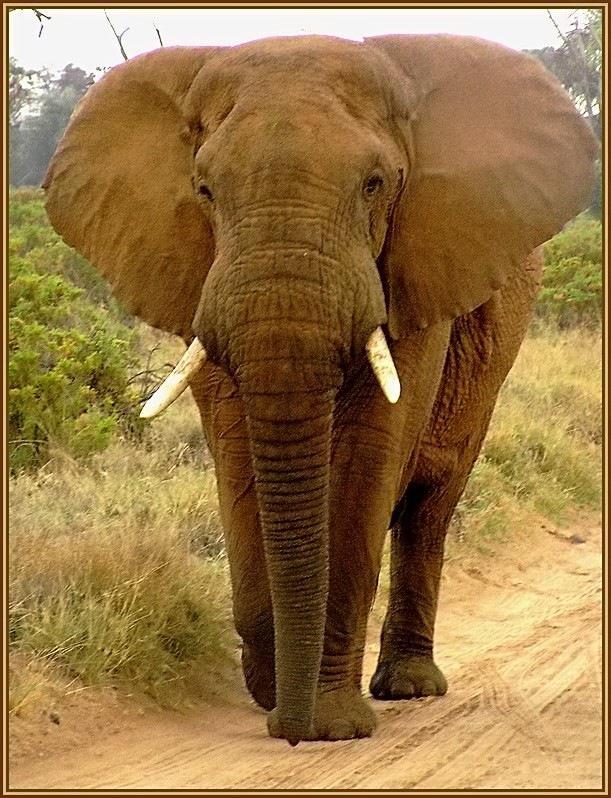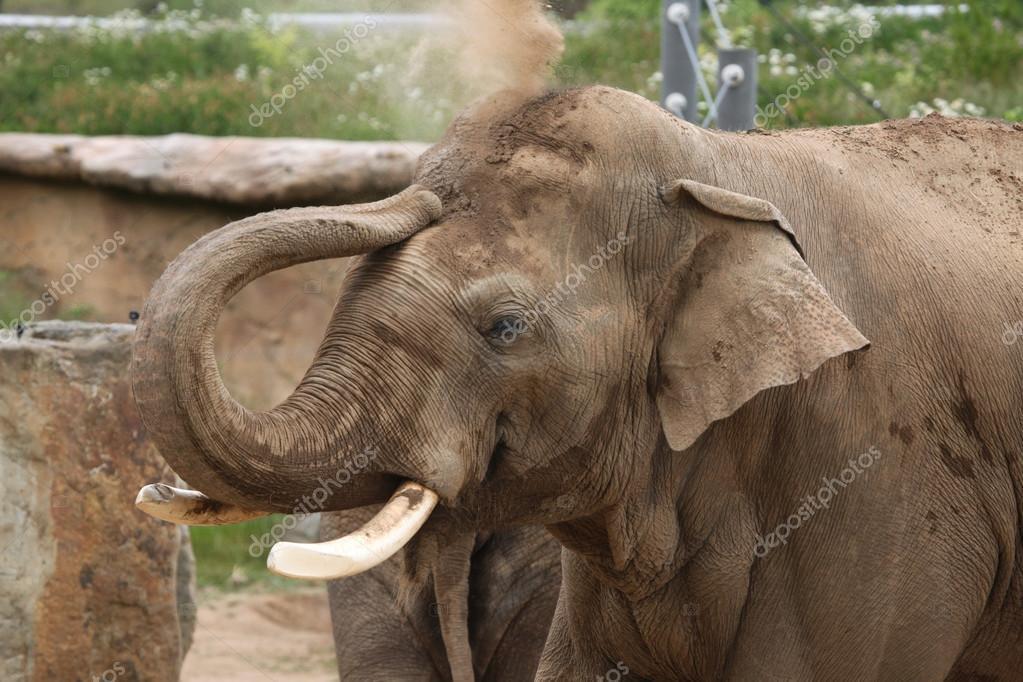The first image is the image on the left, the second image is the image on the right. Evaluate the accuracy of this statement regarding the images: "One image features an elephant with tusks and a lowered trunk, and the other shows an elephant with tusks and a raised curled trunk.". Is it true? Answer yes or no. Yes. The first image is the image on the left, the second image is the image on the right. Evaluate the accuracy of this statement regarding the images: "Exactly two elephants are shown, one with its trunk hanging down, and one with its trunk curled up to its head, but both of them with tusks.". Is it true? Answer yes or no. Yes. 